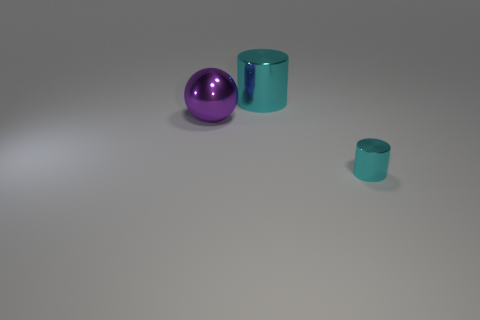Add 2 tiny rubber blocks. How many objects exist? 5 Subtract 2 cylinders. How many cylinders are left? 0 Subtract all purple cylinders. Subtract all brown blocks. How many cylinders are left? 2 Subtract all yellow cylinders. How many blue balls are left? 0 Subtract all big purple shiny balls. Subtract all balls. How many objects are left? 1 Add 1 purple objects. How many purple objects are left? 2 Add 1 cyan spheres. How many cyan spheres exist? 1 Subtract 0 gray cubes. How many objects are left? 3 Subtract all cylinders. How many objects are left? 1 